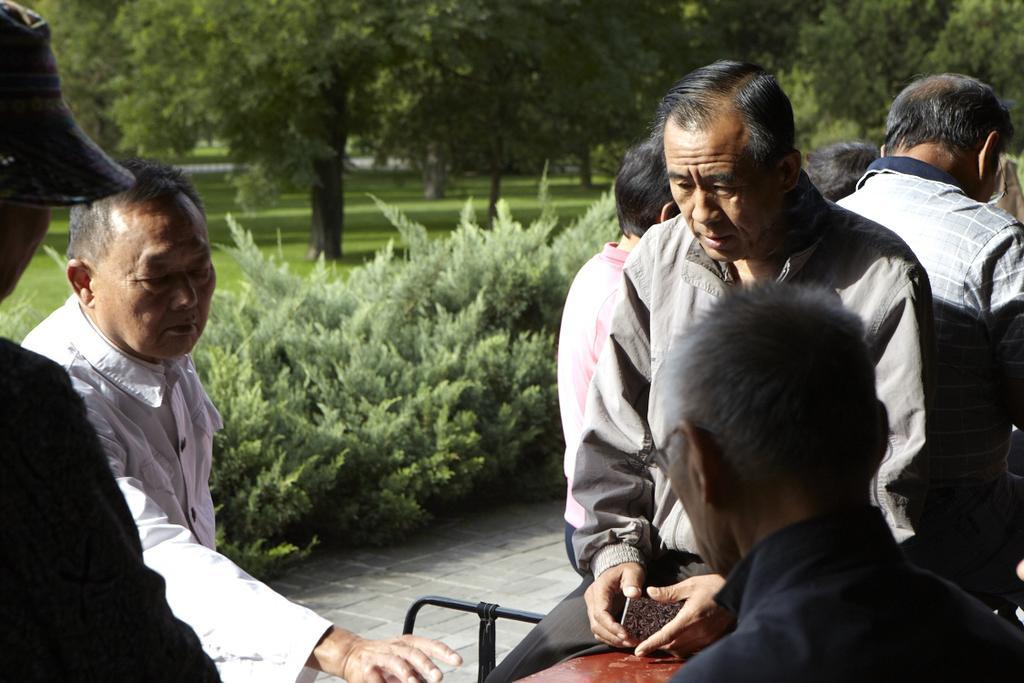In one or two sentences, can you explain what this image depicts? In this picture we can see some people in the front, there are some plants in the middle, in the background there are trees and grass. 